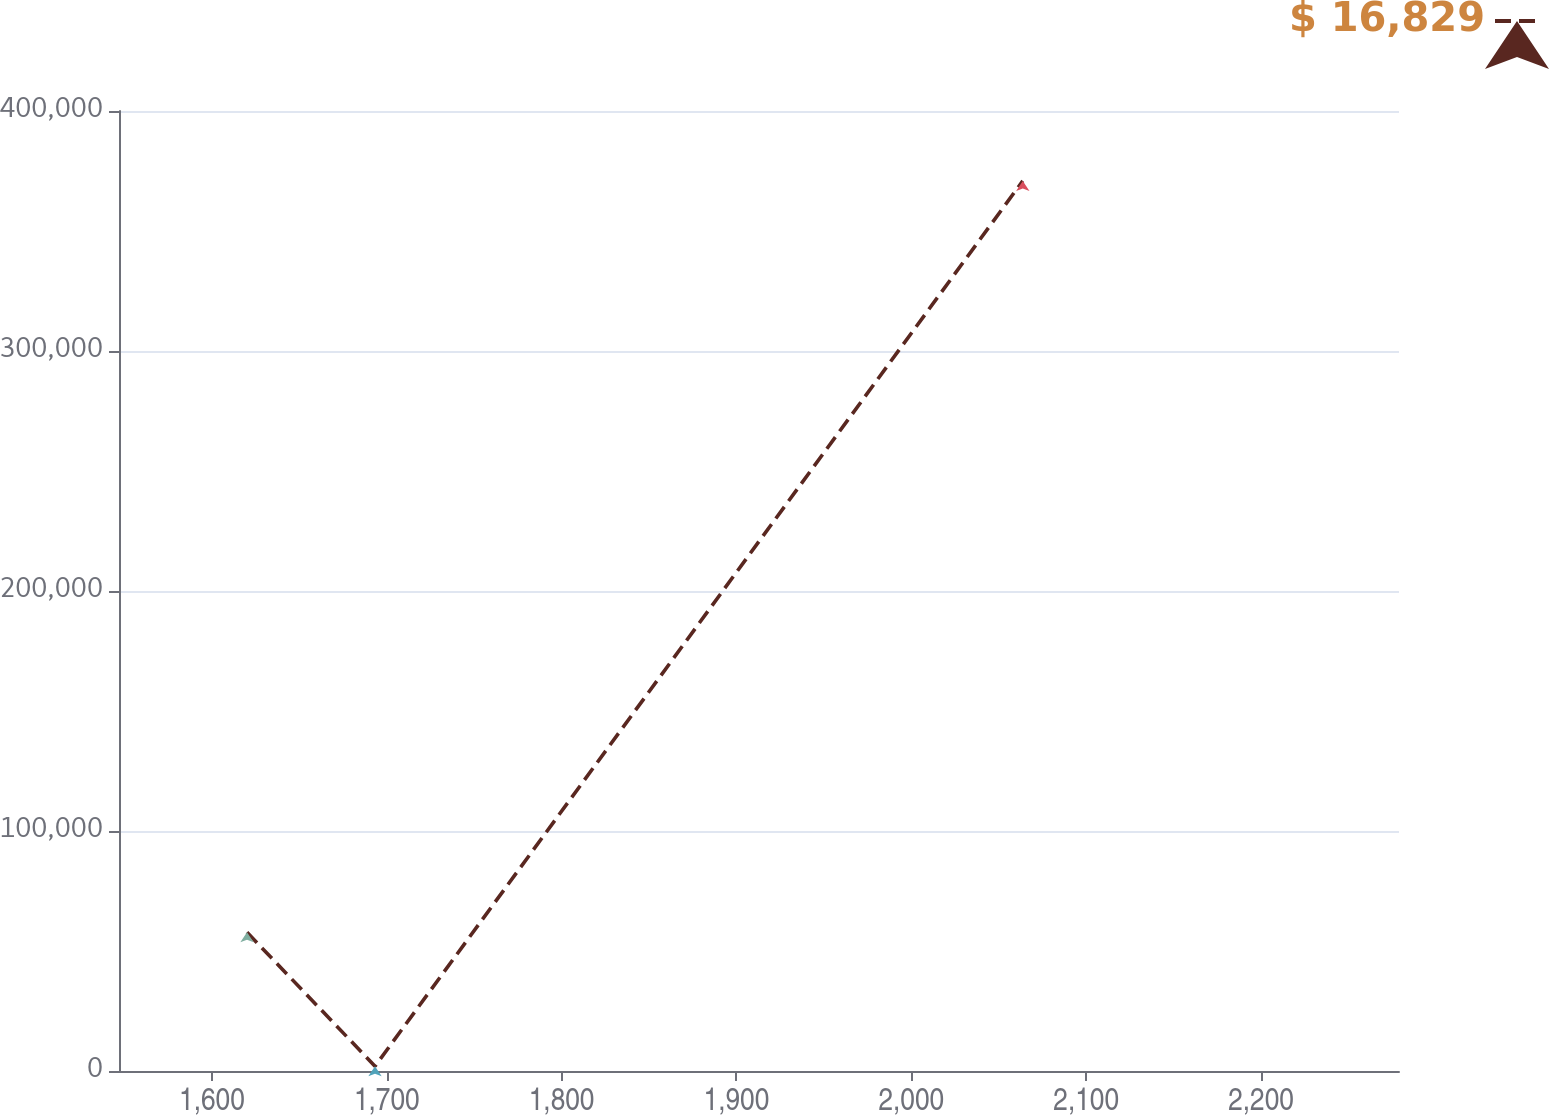<chart> <loc_0><loc_0><loc_500><loc_500><line_chart><ecel><fcel>$ 16,829<nl><fcel>1620.06<fcel>57800.7<nl><fcel>1693.27<fcel>1999.7<nl><fcel>2063.78<fcel>370879<nl><fcel>2352.15<fcel>286874<nl></chart> 